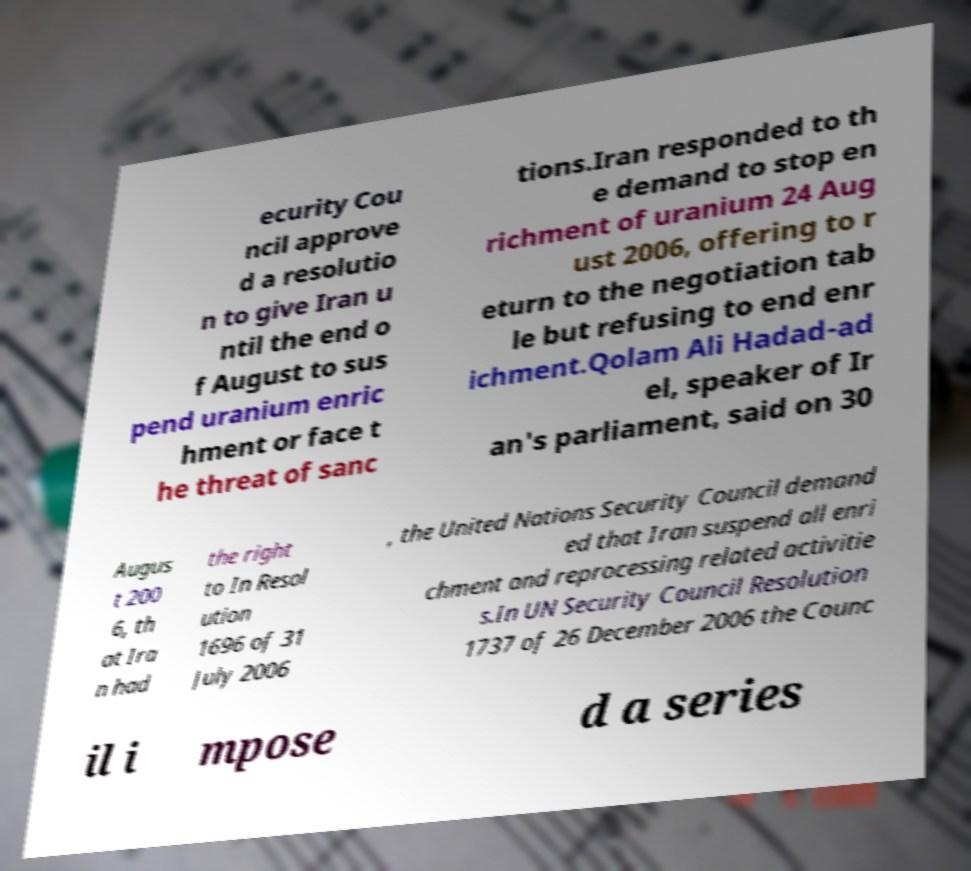Could you assist in decoding the text presented in this image and type it out clearly? ecurity Cou ncil approve d a resolutio n to give Iran u ntil the end o f August to sus pend uranium enric hment or face t he threat of sanc tions.Iran responded to th e demand to stop en richment of uranium 24 Aug ust 2006, offering to r eturn to the negotiation tab le but refusing to end enr ichment.Qolam Ali Hadad-ad el, speaker of Ir an's parliament, said on 30 Augus t 200 6, th at Ira n had the right to In Resol ution 1696 of 31 July 2006 , the United Nations Security Council demand ed that Iran suspend all enri chment and reprocessing related activitie s.In UN Security Council Resolution 1737 of 26 December 2006 the Counc il i mpose d a series 